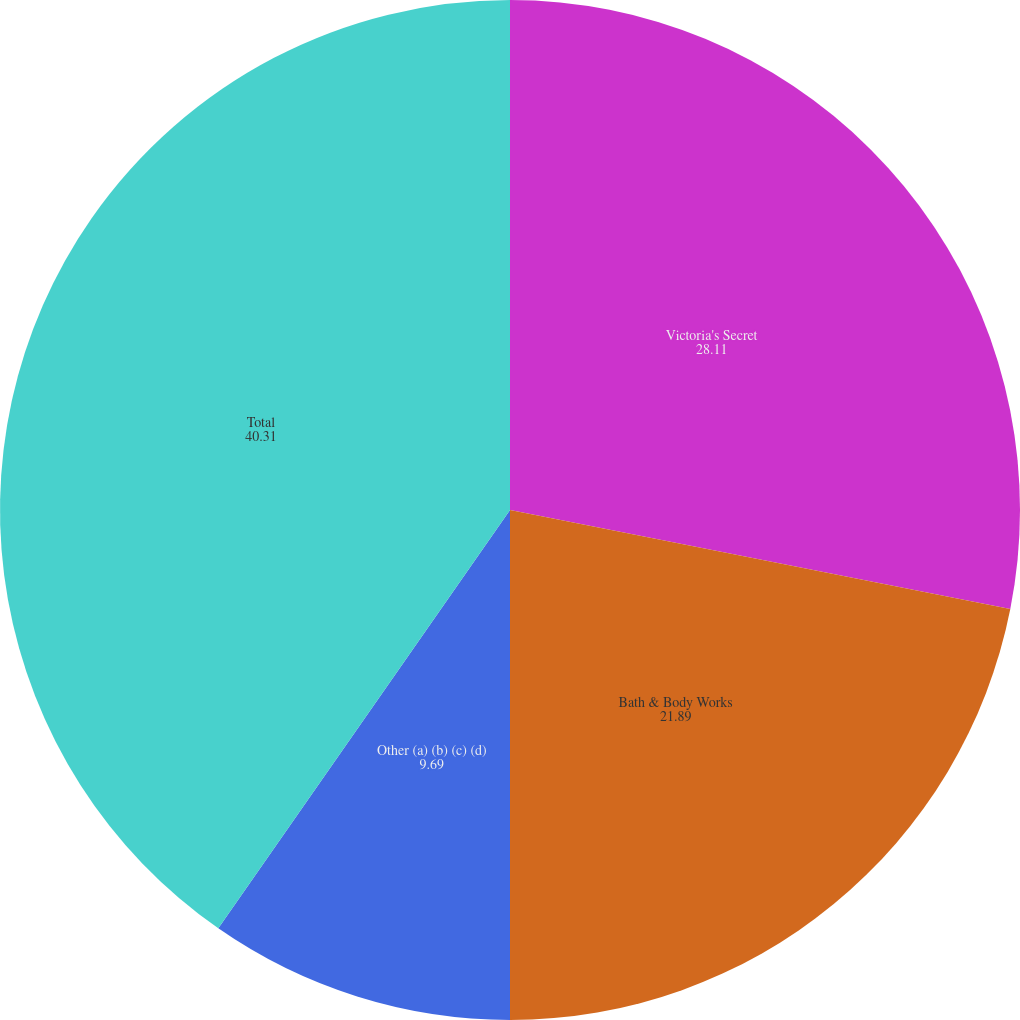<chart> <loc_0><loc_0><loc_500><loc_500><pie_chart><fcel>Victoria's Secret<fcel>Bath & Body Works<fcel>Other (a) (b) (c) (d)<fcel>Total<nl><fcel>28.11%<fcel>21.89%<fcel>9.69%<fcel>40.31%<nl></chart> 